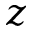Convert formula to latex. <formula><loc_0><loc_0><loc_500><loc_500>z</formula> 